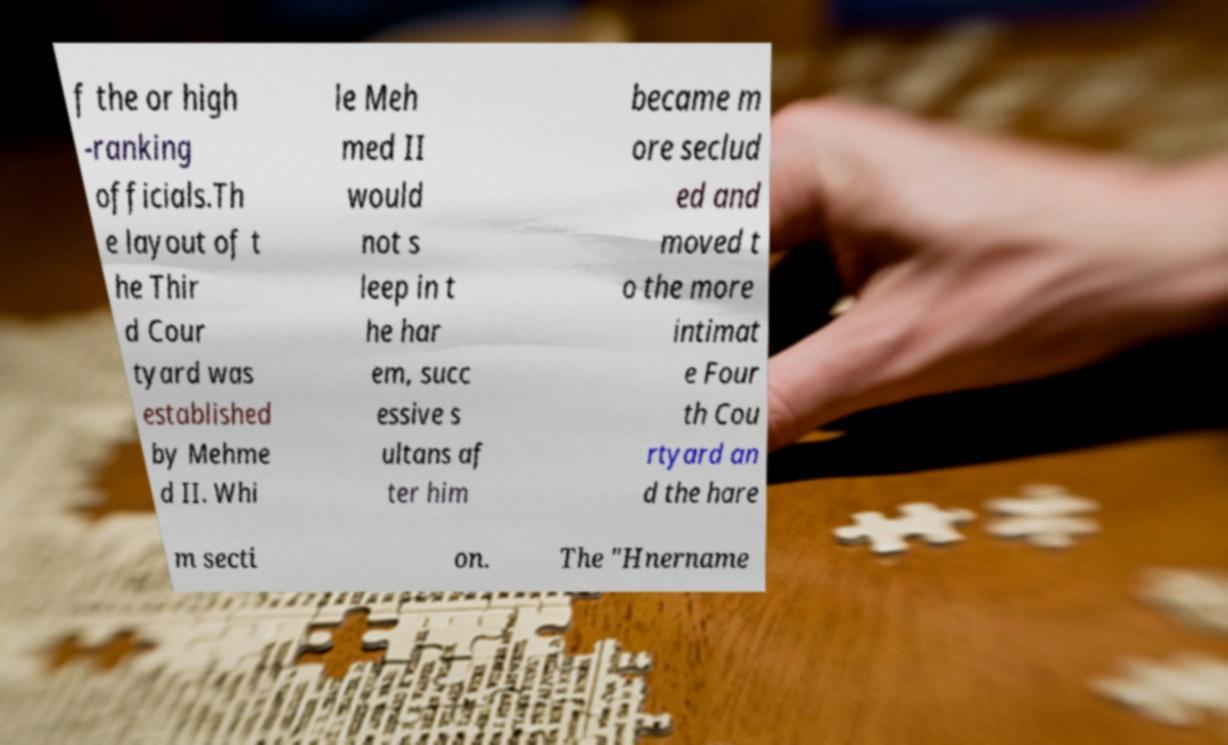Could you assist in decoding the text presented in this image and type it out clearly? f the or high -ranking officials.Th e layout of t he Thir d Cour tyard was established by Mehme d II. Whi le Meh med II would not s leep in t he har em, succ essive s ultans af ter him became m ore seclud ed and moved t o the more intimat e Four th Cou rtyard an d the hare m secti on. The "Hnername 